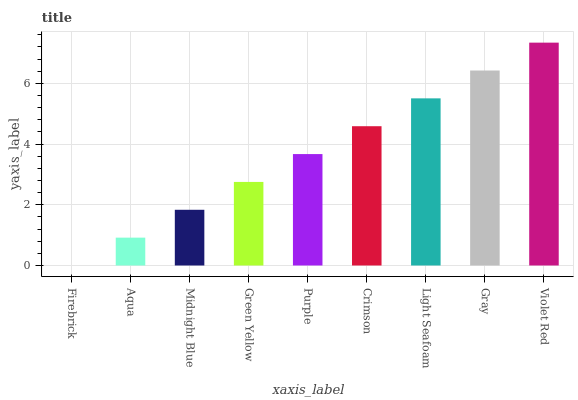Is Firebrick the minimum?
Answer yes or no. Yes. Is Violet Red the maximum?
Answer yes or no. Yes. Is Aqua the minimum?
Answer yes or no. No. Is Aqua the maximum?
Answer yes or no. No. Is Aqua greater than Firebrick?
Answer yes or no. Yes. Is Firebrick less than Aqua?
Answer yes or no. Yes. Is Firebrick greater than Aqua?
Answer yes or no. No. Is Aqua less than Firebrick?
Answer yes or no. No. Is Purple the high median?
Answer yes or no. Yes. Is Purple the low median?
Answer yes or no. Yes. Is Violet Red the high median?
Answer yes or no. No. Is Light Seafoam the low median?
Answer yes or no. No. 